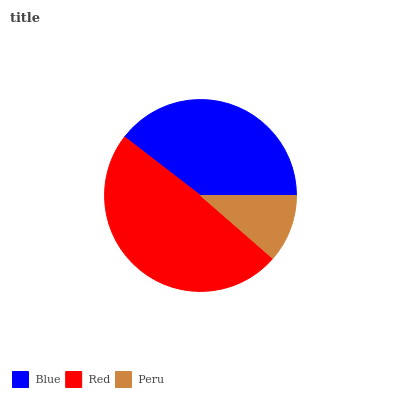Is Peru the minimum?
Answer yes or no. Yes. Is Red the maximum?
Answer yes or no. Yes. Is Red the minimum?
Answer yes or no. No. Is Peru the maximum?
Answer yes or no. No. Is Red greater than Peru?
Answer yes or no. Yes. Is Peru less than Red?
Answer yes or no. Yes. Is Peru greater than Red?
Answer yes or no. No. Is Red less than Peru?
Answer yes or no. No. Is Blue the high median?
Answer yes or no. Yes. Is Blue the low median?
Answer yes or no. Yes. Is Red the high median?
Answer yes or no. No. Is Peru the low median?
Answer yes or no. No. 